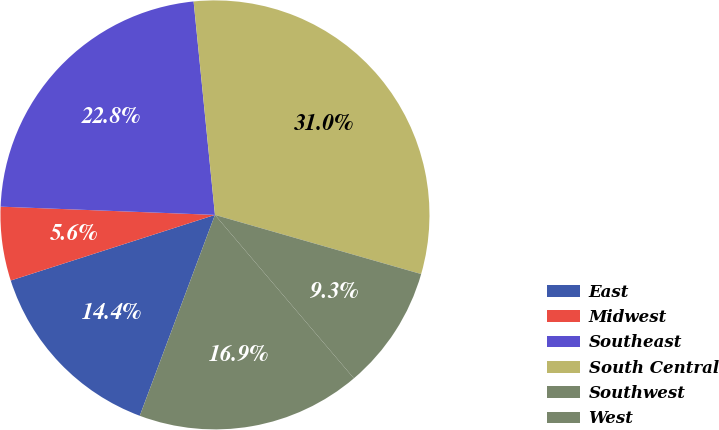Convert chart. <chart><loc_0><loc_0><loc_500><loc_500><pie_chart><fcel>East<fcel>Midwest<fcel>Southeast<fcel>South Central<fcel>Southwest<fcel>West<nl><fcel>14.35%<fcel>5.56%<fcel>22.8%<fcel>31.03%<fcel>9.34%<fcel>16.91%<nl></chart> 